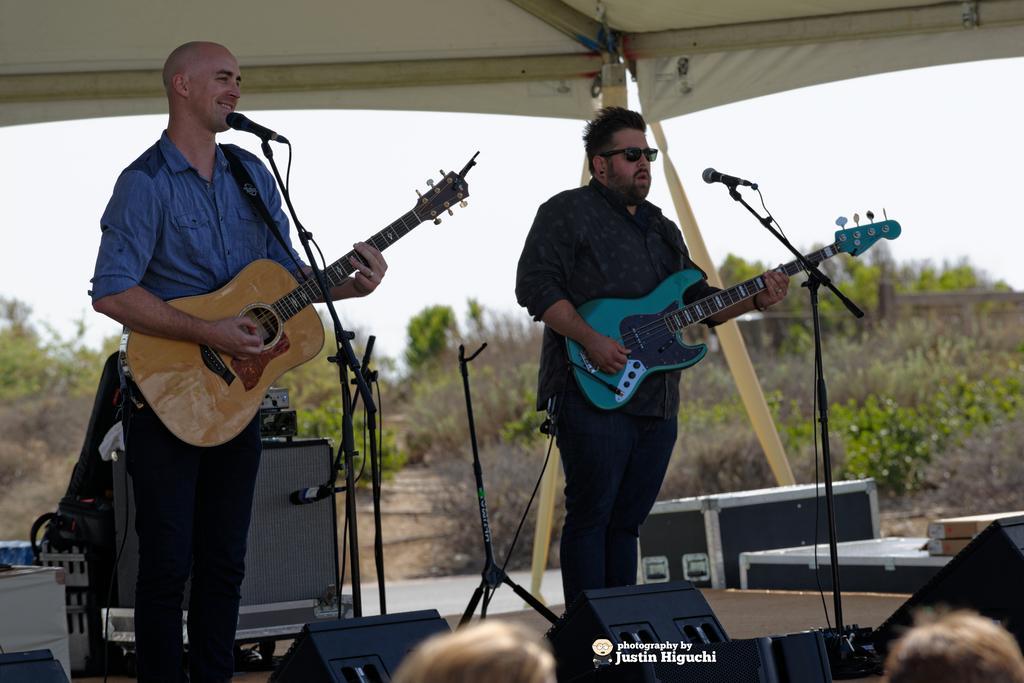Please provide a concise description of this image. This picture is of outside. On the right there is a man wearing black color shirt, playing guitar and standing under the tent. On the left there is a man wearing blue color shirt, smiling, playing guitar and standing under the tent. In the foreground there are some musical instruments and there are microphones attached to the stands. We can see there are two persons. In the background there is a sky and plants and there is a watermark on the image. 